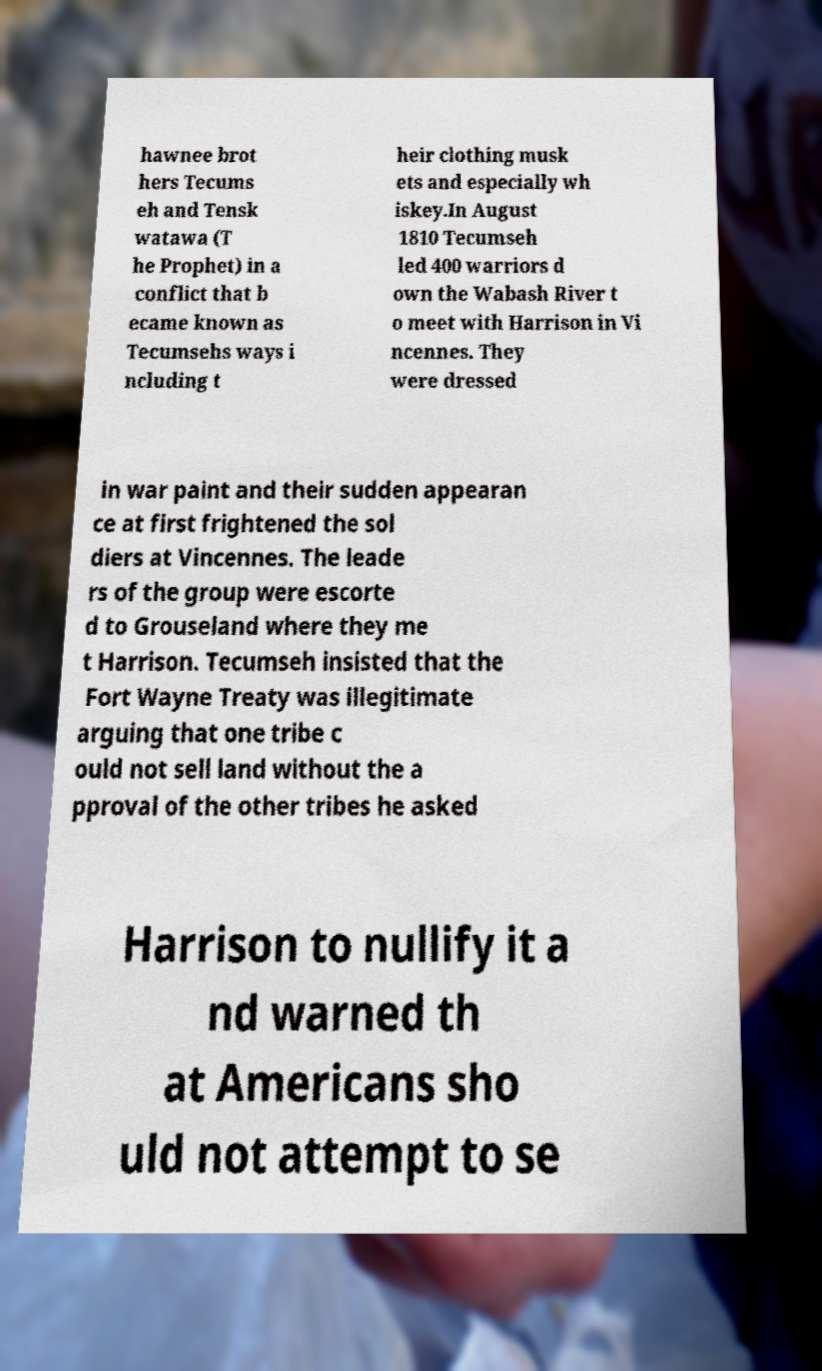For documentation purposes, I need the text within this image transcribed. Could you provide that? hawnee brot hers Tecums eh and Tensk watawa (T he Prophet) in a conflict that b ecame known as Tecumsehs ways i ncluding t heir clothing musk ets and especially wh iskey.In August 1810 Tecumseh led 400 warriors d own the Wabash River t o meet with Harrison in Vi ncennes. They were dressed in war paint and their sudden appearan ce at first frightened the sol diers at Vincennes. The leade rs of the group were escorte d to Grouseland where they me t Harrison. Tecumseh insisted that the Fort Wayne Treaty was illegitimate arguing that one tribe c ould not sell land without the a pproval of the other tribes he asked Harrison to nullify it a nd warned th at Americans sho uld not attempt to se 